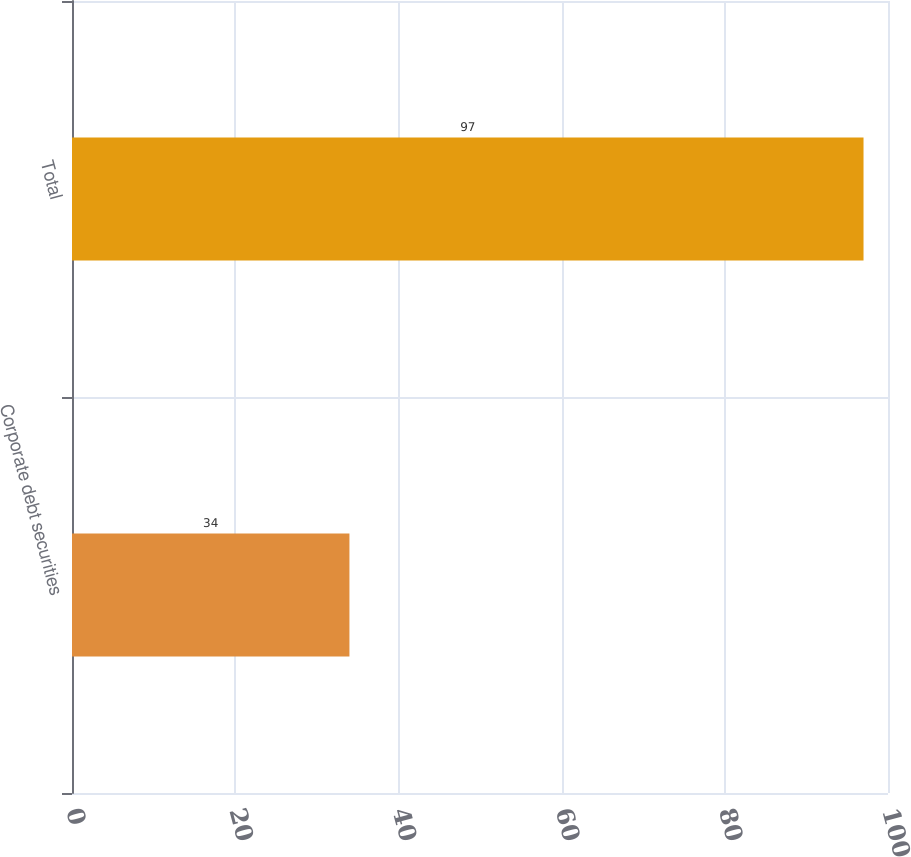Convert chart. <chart><loc_0><loc_0><loc_500><loc_500><bar_chart><fcel>Corporate debt securities<fcel>Total<nl><fcel>34<fcel>97<nl></chart> 